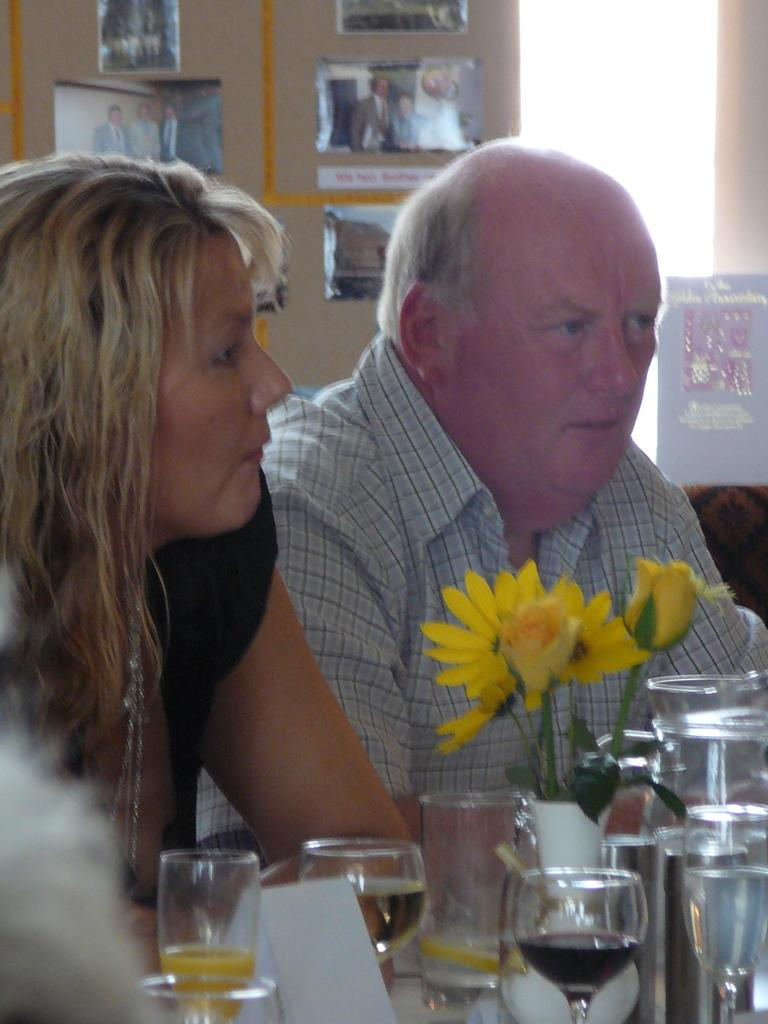How many people are in the image? There is a woman and a man in the image. What objects can be seen at the bottom of the image? There are glasses and a flower vase at the bottom of the image. What type of objects are present at the bottom of the image? There are objects at the bottom of the image, including glasses and a flower vase. What can be seen in the background of the image? There is a wall, photographs, and a poster in the background of the image. How much debt does the woman owe in the image? There is no indication of debt in the image; it only shows a woman, a man, and various objects. What type of pump is visible in the image? There is no pump present in the image. 